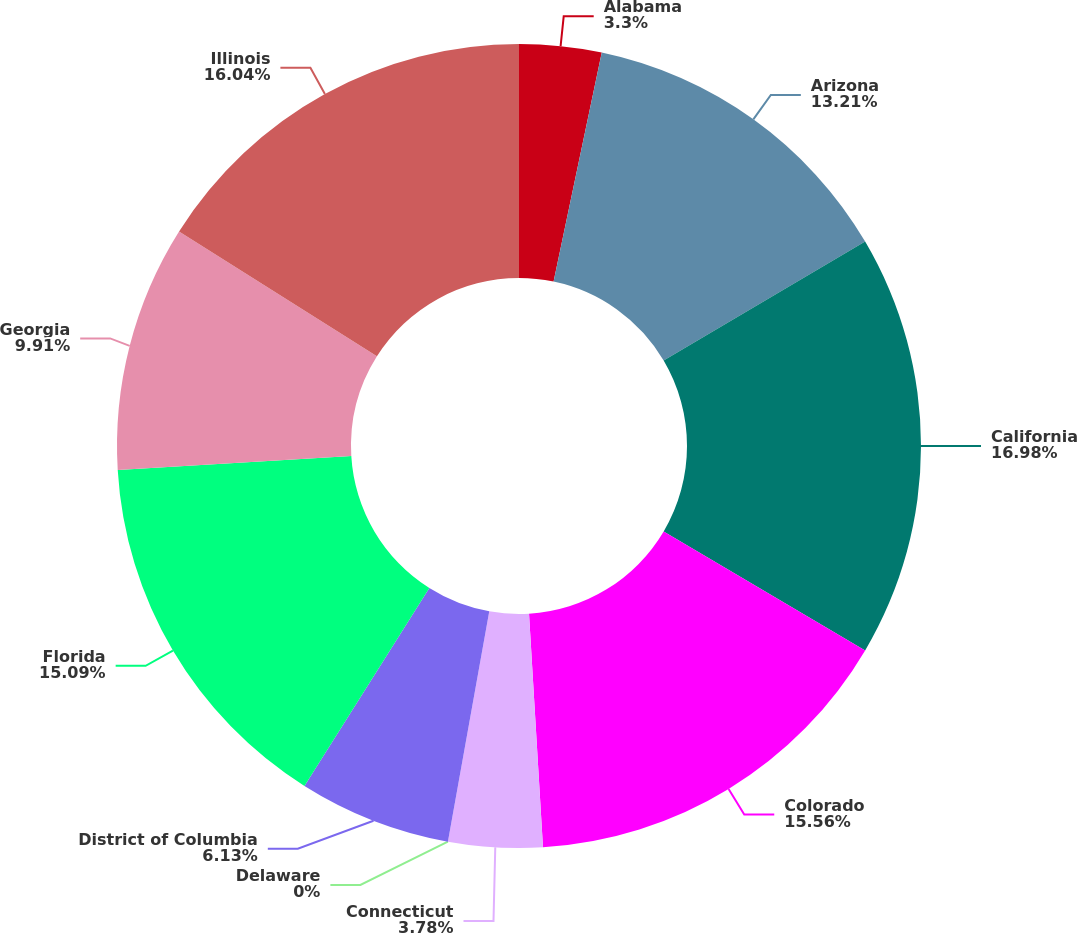Convert chart to OTSL. <chart><loc_0><loc_0><loc_500><loc_500><pie_chart><fcel>Alabama<fcel>Arizona<fcel>California<fcel>Colorado<fcel>Connecticut<fcel>Delaware<fcel>District of Columbia<fcel>Florida<fcel>Georgia<fcel>Illinois<nl><fcel>3.3%<fcel>13.21%<fcel>16.98%<fcel>15.56%<fcel>3.78%<fcel>0.0%<fcel>6.13%<fcel>15.09%<fcel>9.91%<fcel>16.04%<nl></chart> 